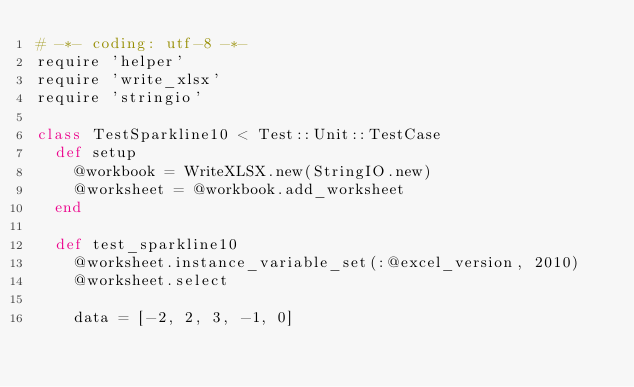Convert code to text. <code><loc_0><loc_0><loc_500><loc_500><_Ruby_># -*- coding: utf-8 -*-
require 'helper'
require 'write_xlsx'
require 'stringio'

class TestSparkline10 < Test::Unit::TestCase
  def setup
    @workbook = WriteXLSX.new(StringIO.new)
    @worksheet = @workbook.add_worksheet
  end

  def test_sparkline10
    @worksheet.instance_variable_set(:@excel_version, 2010)
    @worksheet.select

    data = [-2, 2, 3, -1, 0]
</code> 